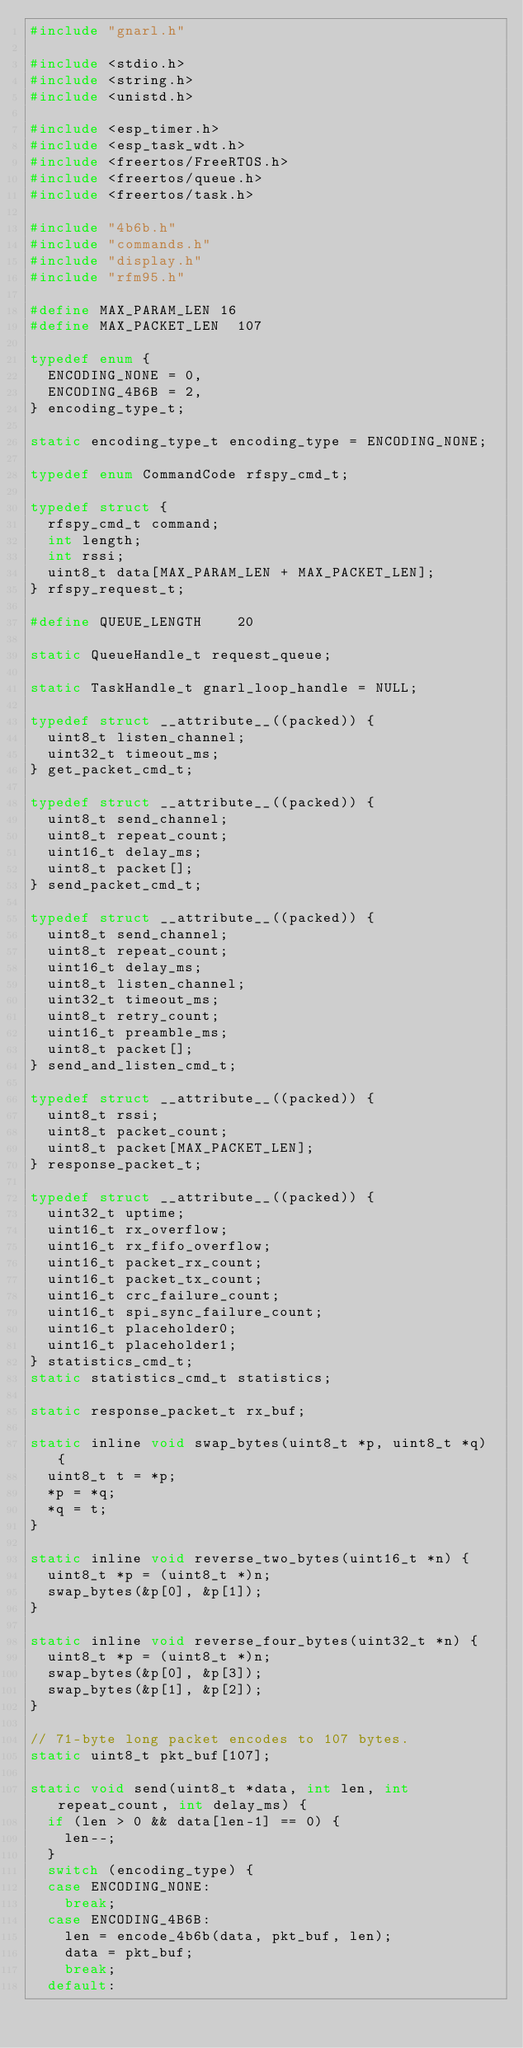Convert code to text. <code><loc_0><loc_0><loc_500><loc_500><_C_>#include "gnarl.h"

#include <stdio.h>
#include <string.h>
#include <unistd.h>

#include <esp_timer.h>
#include <esp_task_wdt.h>
#include <freertos/FreeRTOS.h>
#include <freertos/queue.h>
#include <freertos/task.h>

#include "4b6b.h"
#include "commands.h"
#include "display.h"
#include "rfm95.h"

#define MAX_PARAM_LEN	16
#define MAX_PACKET_LEN	107

typedef enum {
	ENCODING_NONE = 0,
	ENCODING_4B6B = 2,
} encoding_type_t;

static encoding_type_t encoding_type = ENCODING_NONE;

typedef enum CommandCode rfspy_cmd_t;

typedef struct {
	rfspy_cmd_t command;
	int length;
	int rssi;
	uint8_t data[MAX_PARAM_LEN + MAX_PACKET_LEN];
} rfspy_request_t;

#define QUEUE_LENGTH		20

static QueueHandle_t request_queue;

static TaskHandle_t gnarl_loop_handle = NULL;

typedef struct __attribute__((packed)) {
	uint8_t listen_channel;
	uint32_t timeout_ms;
} get_packet_cmd_t;

typedef struct __attribute__((packed)) {
	uint8_t send_channel;
	uint8_t repeat_count;
	uint16_t delay_ms;
	uint8_t packet[];
} send_packet_cmd_t;

typedef struct __attribute__((packed)) {
	uint8_t send_channel;
	uint8_t repeat_count;
	uint16_t delay_ms;
	uint8_t listen_channel;
	uint32_t timeout_ms;
	uint8_t retry_count;
	uint16_t preamble_ms;
	uint8_t packet[];
} send_and_listen_cmd_t;

typedef struct __attribute__((packed)) {
	uint8_t rssi;
	uint8_t packet_count;
	uint8_t packet[MAX_PACKET_LEN];
} response_packet_t;

typedef struct __attribute__((packed)) {
	uint32_t uptime;
	uint16_t rx_overflow;
	uint16_t rx_fifo_overflow;
	uint16_t packet_rx_count;
	uint16_t packet_tx_count;
	uint16_t crc_failure_count;
	uint16_t spi_sync_failure_count;
	uint16_t placeholder0;
	uint16_t placeholder1;
} statistics_cmd_t;
static statistics_cmd_t statistics;

static response_packet_t rx_buf;

static inline void swap_bytes(uint8_t *p, uint8_t *q) {
	uint8_t t = *p;
	*p = *q;
	*q = t;
}

static inline void reverse_two_bytes(uint16_t *n) {
	uint8_t *p = (uint8_t *)n;
	swap_bytes(&p[0], &p[1]);
}

static inline void reverse_four_bytes(uint32_t *n) {
	uint8_t *p = (uint8_t *)n;
	swap_bytes(&p[0], &p[3]);
	swap_bytes(&p[1], &p[2]);
}

// 71-byte long packet encodes to 107 bytes.
static uint8_t pkt_buf[107];

static void send(uint8_t *data, int len, int repeat_count, int delay_ms) {
	if (len > 0 && data[len-1] == 0) {
		len--;
	}
	switch (encoding_type) {
	case ENCODING_NONE:
		break;
	case ENCODING_4B6B:
		len = encode_4b6b(data, pkt_buf, len);
		data = pkt_buf;
		break;
	default:</code> 